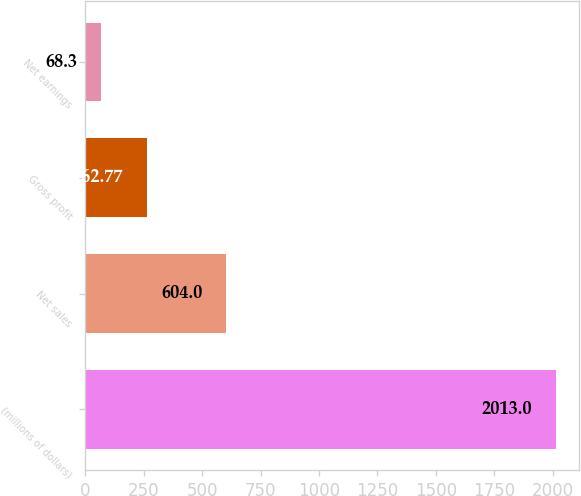Convert chart to OTSL. <chart><loc_0><loc_0><loc_500><loc_500><bar_chart><fcel>(millions of dollars)<fcel>Net sales<fcel>Gross profit<fcel>Net earnings<nl><fcel>2013<fcel>604<fcel>262.77<fcel>68.3<nl></chart> 